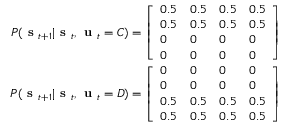Convert formula to latex. <formula><loc_0><loc_0><loc_500><loc_500>\begin{array} { r } { P ( s _ { t + 1 } | s _ { t } , u _ { t } = C ) = \left [ \begin{array} { l l l l } { 0 . 5 } & { 0 . 5 } & { 0 . 5 } & { 0 . 5 } \\ { 0 . 5 } & { 0 . 5 } & { 0 . 5 } & { 0 . 5 } \\ { 0 } & { 0 } & { 0 } & { 0 } \\ { 0 } & { 0 } & { 0 } & { 0 } \end{array} \right ] } \\ { P ( s _ { t + 1 } | s _ { t } , u _ { t } = D ) = \left [ \begin{array} { l l l l } { 0 } & { 0 } & { 0 } & { 0 } \\ { 0 } & { 0 } & { 0 } & { 0 } \\ { 0 . 5 } & { 0 . 5 } & { 0 . 5 } & { 0 . 5 } \\ { 0 . 5 } & { 0 . 5 } & { 0 . 5 } & { 0 . 5 } \end{array} \right ] } \end{array}</formula> 